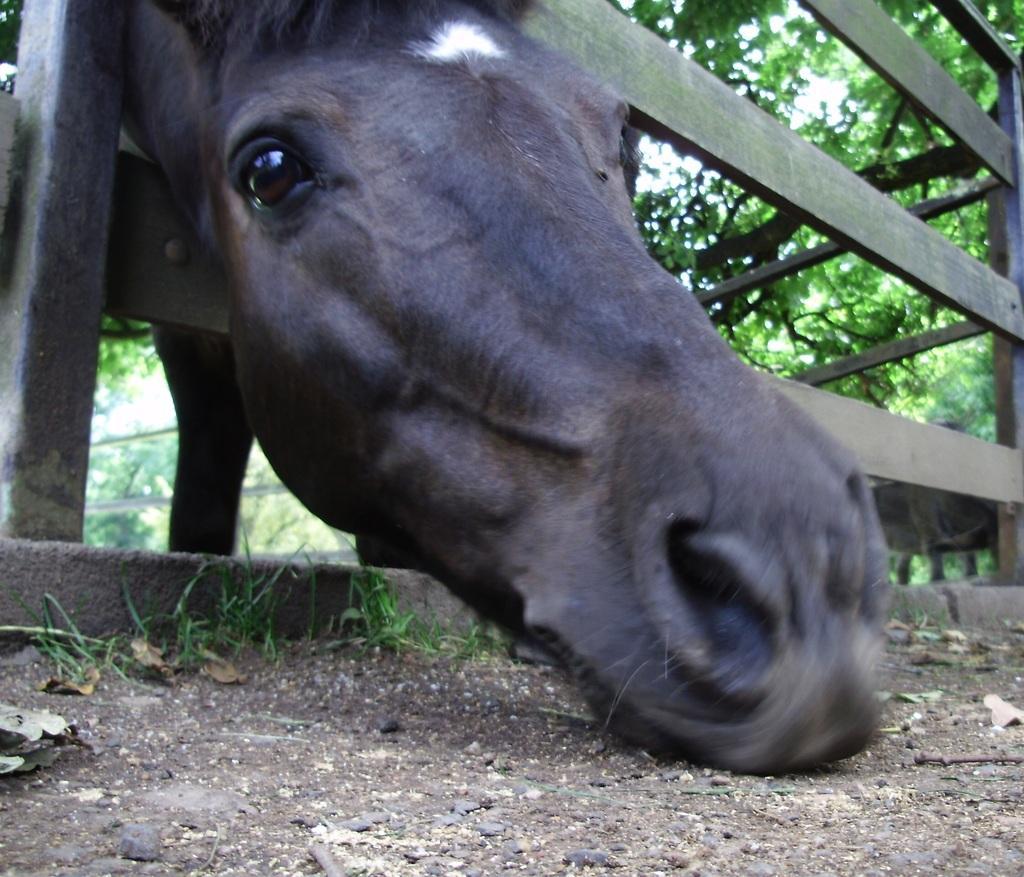Describe this image in one or two sentences. In this image I can see an animal head visible on the fence and I can see trees at the top. 